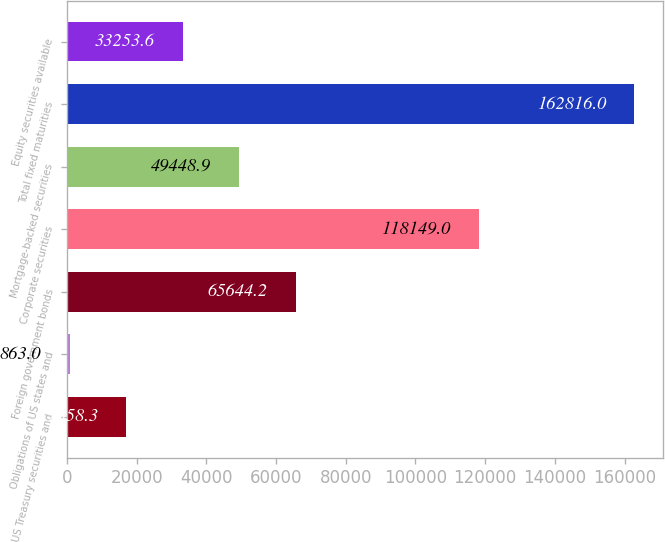<chart> <loc_0><loc_0><loc_500><loc_500><bar_chart><fcel>US Treasury securities and<fcel>Obligations of US states and<fcel>Foreign government bonds<fcel>Corporate securities<fcel>Mortgage-backed securities<fcel>Total fixed maturities<fcel>Equity securities available<nl><fcel>17058.3<fcel>863<fcel>65644.2<fcel>118149<fcel>49448.9<fcel>162816<fcel>33253.6<nl></chart> 